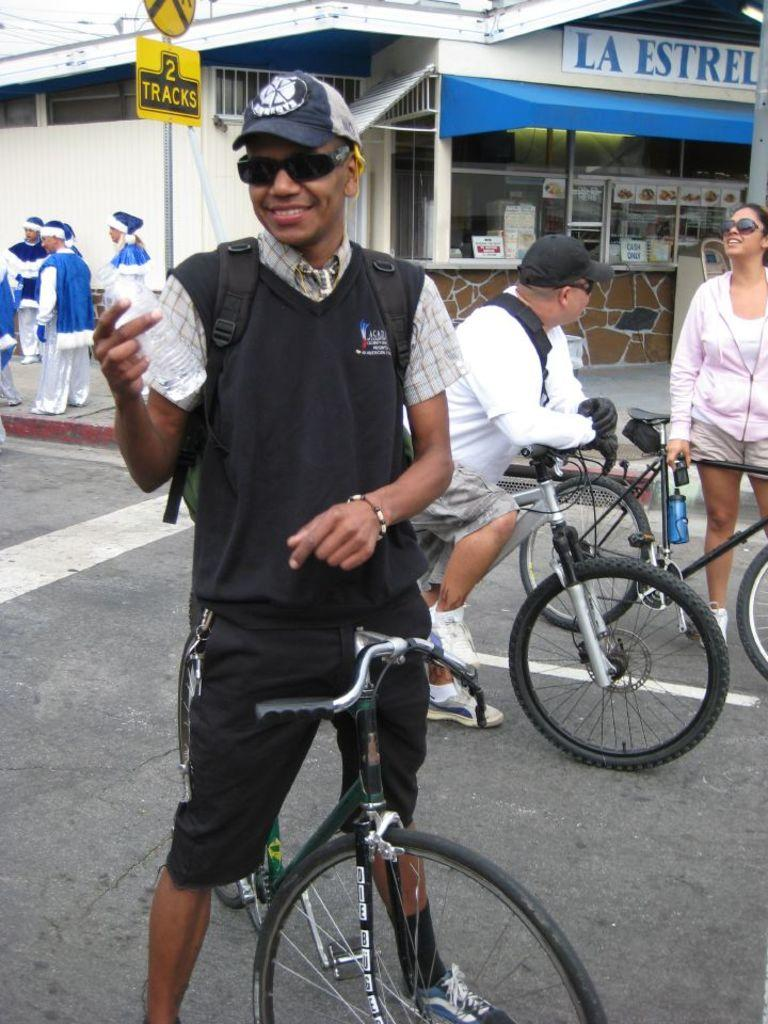What is the main subject of the image? There is a person in the image. What is the person wearing? The person is wearing a black dress. What is the person doing in the image? The person is standing on a bicycle. What object is the person holding in their hand? The person is holding a water bottle in their hand. Can you describe the background of the image? There are people visible behind the person on the bicycle. Is the person in the image a slave? There is no indication in the image that the person is a slave, and the term "slave" is not relevant to the image. 